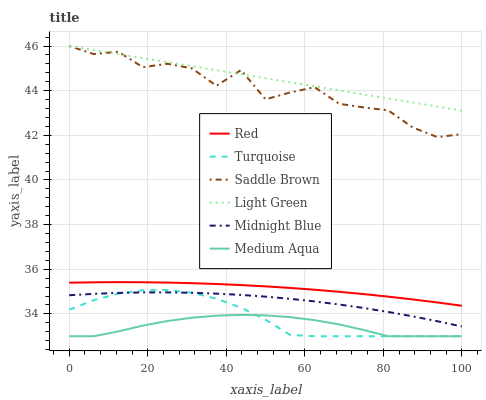Does Medium Aqua have the minimum area under the curve?
Answer yes or no. Yes. Does Light Green have the maximum area under the curve?
Answer yes or no. Yes. Does Midnight Blue have the minimum area under the curve?
Answer yes or no. No. Does Midnight Blue have the maximum area under the curve?
Answer yes or no. No. Is Light Green the smoothest?
Answer yes or no. Yes. Is Saddle Brown the roughest?
Answer yes or no. Yes. Is Midnight Blue the smoothest?
Answer yes or no. No. Is Midnight Blue the roughest?
Answer yes or no. No. Does Turquoise have the lowest value?
Answer yes or no. Yes. Does Midnight Blue have the lowest value?
Answer yes or no. No. Does Saddle Brown have the highest value?
Answer yes or no. Yes. Does Midnight Blue have the highest value?
Answer yes or no. No. Is Midnight Blue less than Saddle Brown?
Answer yes or no. Yes. Is Saddle Brown greater than Medium Aqua?
Answer yes or no. Yes. Does Medium Aqua intersect Turquoise?
Answer yes or no. Yes. Is Medium Aqua less than Turquoise?
Answer yes or no. No. Is Medium Aqua greater than Turquoise?
Answer yes or no. No. Does Midnight Blue intersect Saddle Brown?
Answer yes or no. No. 